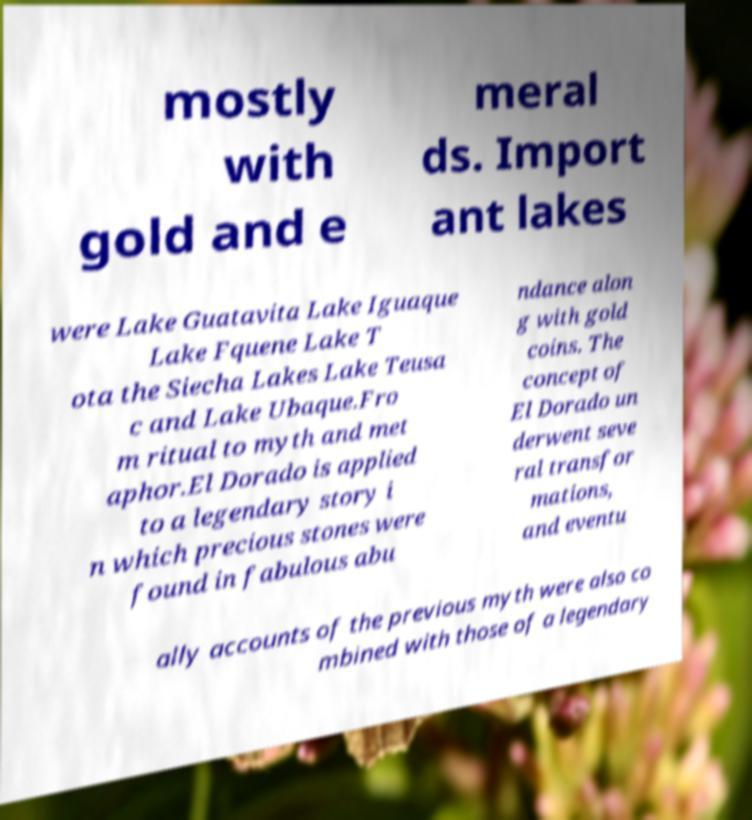Please identify and transcribe the text found in this image. mostly with gold and e meral ds. Import ant lakes were Lake Guatavita Lake Iguaque Lake Fquene Lake T ota the Siecha Lakes Lake Teusa c and Lake Ubaque.Fro m ritual to myth and met aphor.El Dorado is applied to a legendary story i n which precious stones were found in fabulous abu ndance alon g with gold coins. The concept of El Dorado un derwent seve ral transfor mations, and eventu ally accounts of the previous myth were also co mbined with those of a legendary 